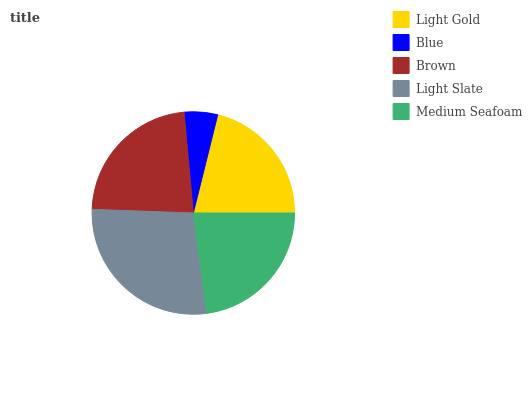Is Blue the minimum?
Answer yes or no. Yes. Is Light Slate the maximum?
Answer yes or no. Yes. Is Brown the minimum?
Answer yes or no. No. Is Brown the maximum?
Answer yes or no. No. Is Brown greater than Blue?
Answer yes or no. Yes. Is Blue less than Brown?
Answer yes or no. Yes. Is Blue greater than Brown?
Answer yes or no. No. Is Brown less than Blue?
Answer yes or no. No. Is Medium Seafoam the high median?
Answer yes or no. Yes. Is Medium Seafoam the low median?
Answer yes or no. Yes. Is Brown the high median?
Answer yes or no. No. Is Brown the low median?
Answer yes or no. No. 